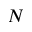<formula> <loc_0><loc_0><loc_500><loc_500>N</formula> 